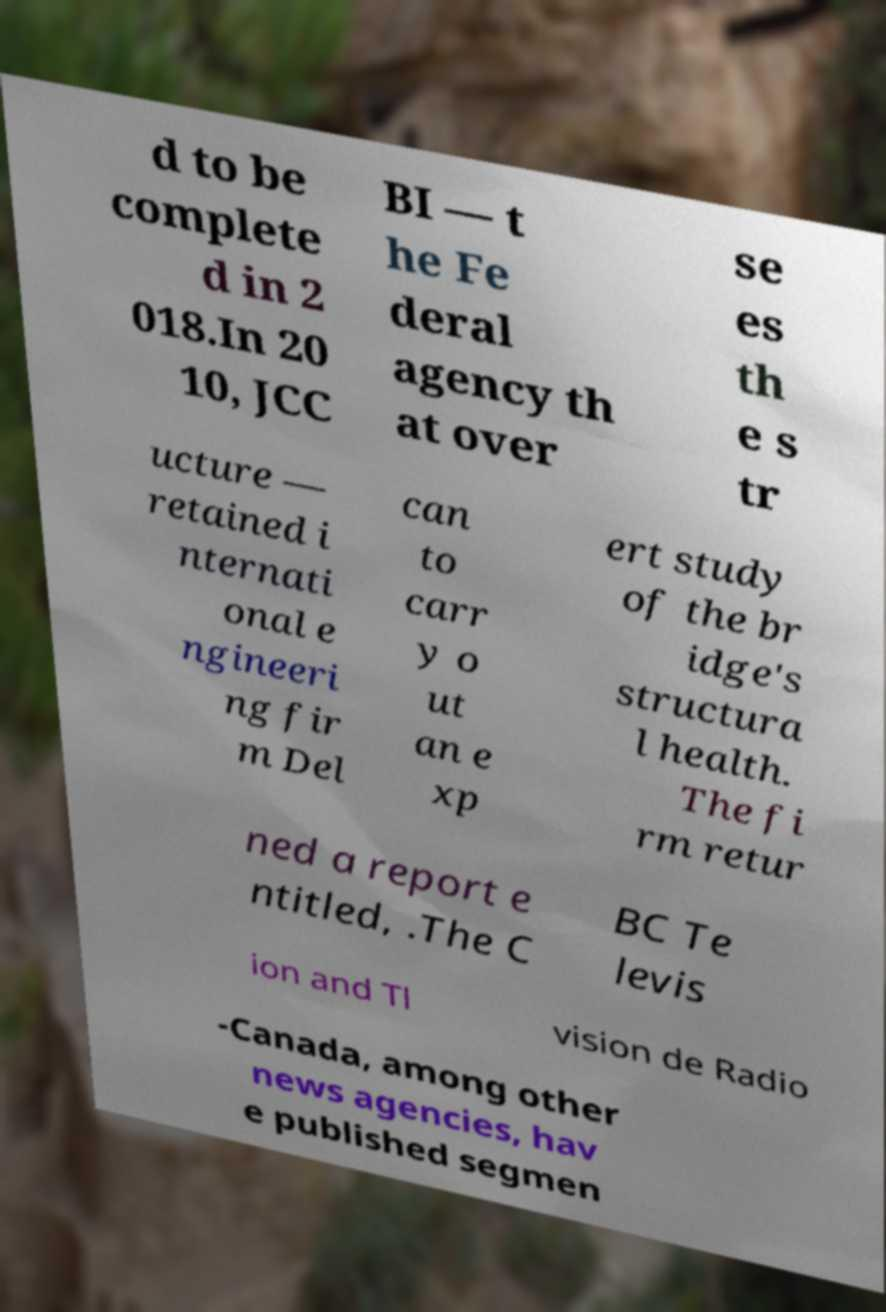Please identify and transcribe the text found in this image. d to be complete d in 2 018.In 20 10, JCC BI — t he Fe deral agency th at over se es th e s tr ucture — retained i nternati onal e ngineeri ng fir m Del can to carr y o ut an e xp ert study of the br idge's structura l health. The fi rm retur ned a report e ntitled, .The C BC Te levis ion and Tl vision de Radio -Canada, among other news agencies, hav e published segmen 